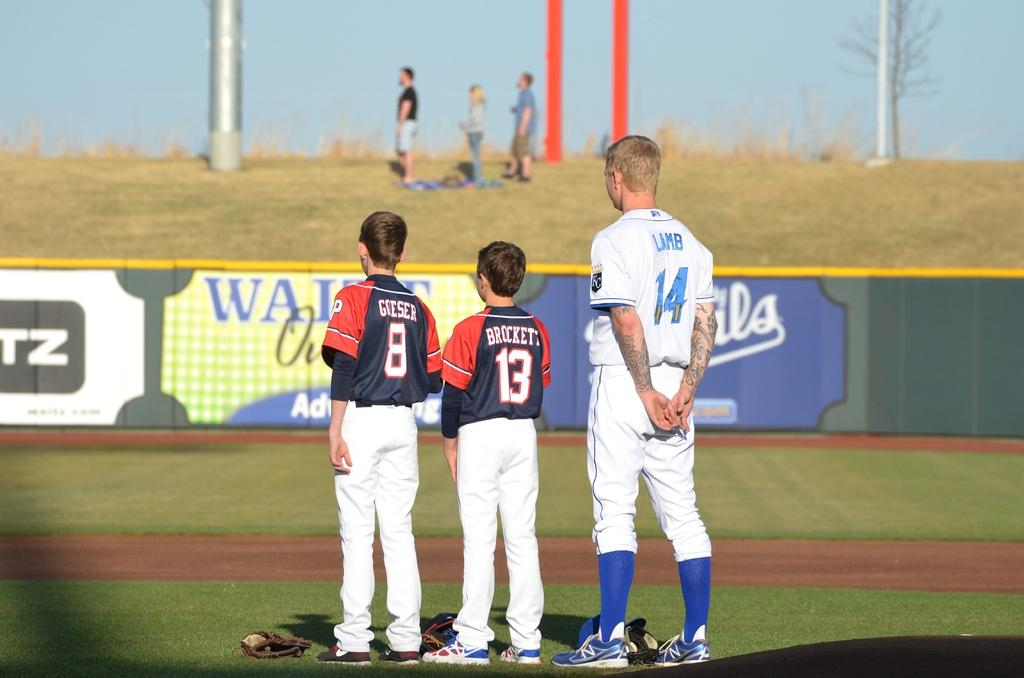Provide a one-sentence caption for the provided image. Two brunette boys in red and blue jerseys named Goeser and Brockett stand next to a taller blonde man in a white jersey named Lamb stand on a baseball field. 